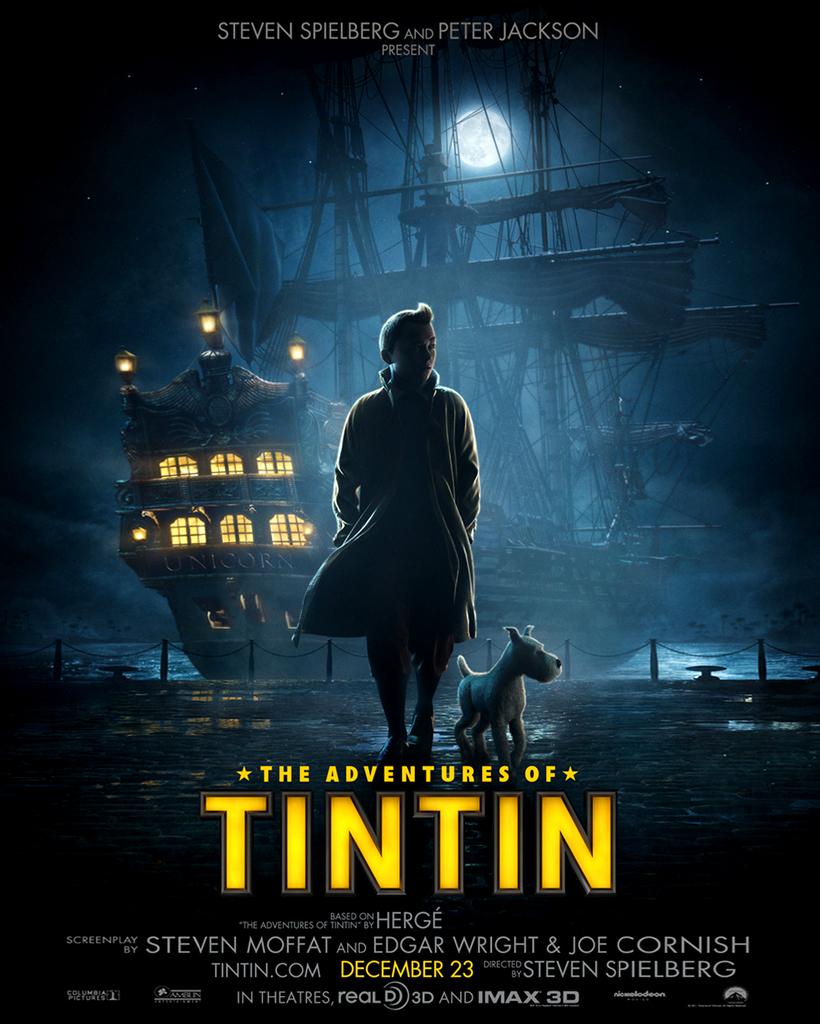When does it come out?
Your answer should be very brief. December 23. What is this movie called?
Your response must be concise. The adventures of tintin. 